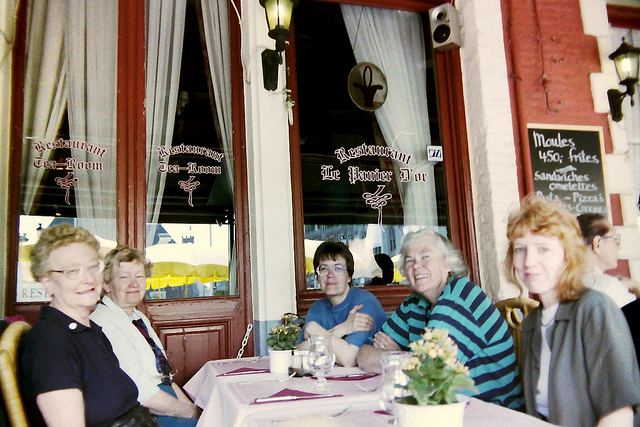Please identify all text content in this image. Dive moules REST Pizza Sandwitches 450 Room Restaurant Restaurant 